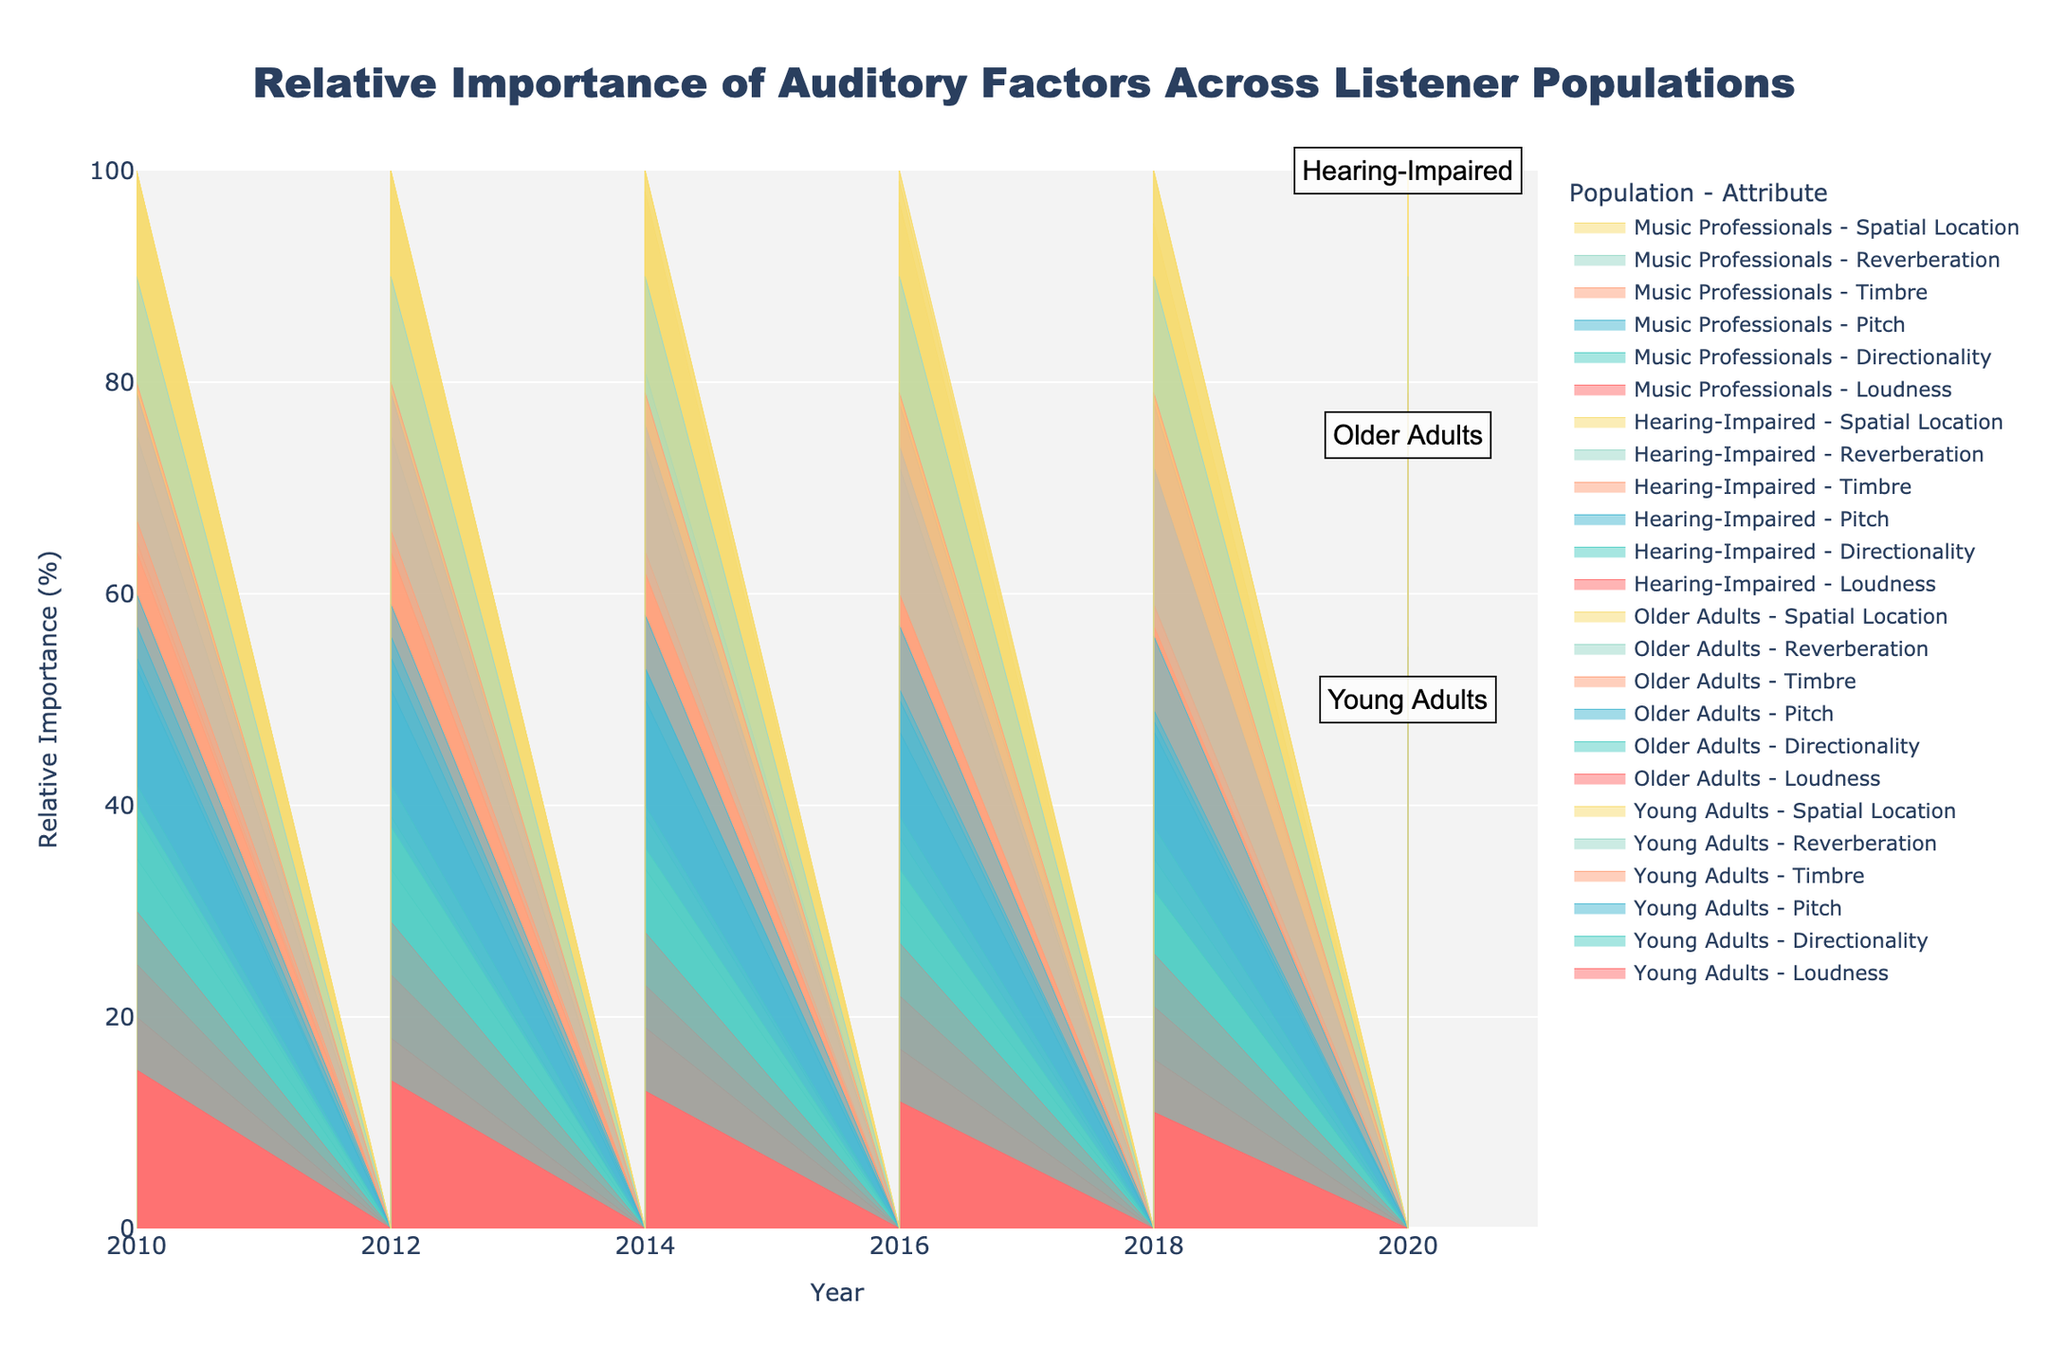What's the title of the plotted figure? The title of the figure is displayed at the top. It reads, "Relative Importance of Auditory Factors Across Listener Populations," indicating the study focus and what is being compared.
Answer: Relative Importance of Auditory Factors Across Listener Populations What auditory attribute remains most important for Hearing-Impaired listeners over time? By examining the stacked areas for the Hearing-Impaired population, we can see which attribute has consistently the largest area over the years. Spatial Location remains the most important attribute.
Answer: Spatial Location How has the importance of 'Loudness' changed for Young Adults from 2010 to 2020? By looking at the 'Loudness' layer for Young Adults in the figure, we see it decreases gradually from 20% in 2010 to 14% in 2020.
Answer: Decreased What percentage of importance does 'Reverberation' have for Older Adults in 2020 compared to 2010? Observing the part of the stack for 'Reverberation' in Older Adults, it is about 15% in 2010 and increases to around 20% by 2020.
Answer: Increased by 5% Between Music Professionals and Young Adults, which group places more importance on 'Pitch' in 2020? By comparing the height of the 'Pitch' stack for both Music Professionals and Young Adults in 2020, Music Professionals prioritize Pitch more with approximately 25% compared to 14%.
Answer: Music Professionals In which year did Directionality peak for the Older Adults group? Locate the highest point of the Directionality stack for Older Adults, which peaks in 2014 with the relative importance being around 16%.
Answer: 2014 Combining the importance of 'Loudness' and 'Directionality' for Hearing-Impaired in 2016, what is the percentage? From the figure, 'Loudness' is about 27% and 'Directionality' is about 12% in 2016, so add them together to get 27% + 12% = 39%.
Answer: 39% Which auditory attribute shows the least variation among all groups? By examining stacks of each auditory attribute across all populations in different years, the one with the least height change across groups and years will be 'Timbre'.
Answer: Timbre How much did the importance of 'Spatial Location' increase for Older Adults from 2010 to 2020? For Older Adults, Spatial Location rose from 21% in 2010 to 24% in 2020, indicating an increase of 3%.
Answer: 3% Which group sees a steady rise in the importance of 'Reverberation' from 2010 to 2020, achieving the highest percentage at the end? By following the 'Reverberation' layers, you will observe that Hearing-Impaired listeners consistently see an increment, achieving the highest at 16% in 2020.
Answer: Hearing-Impaired 